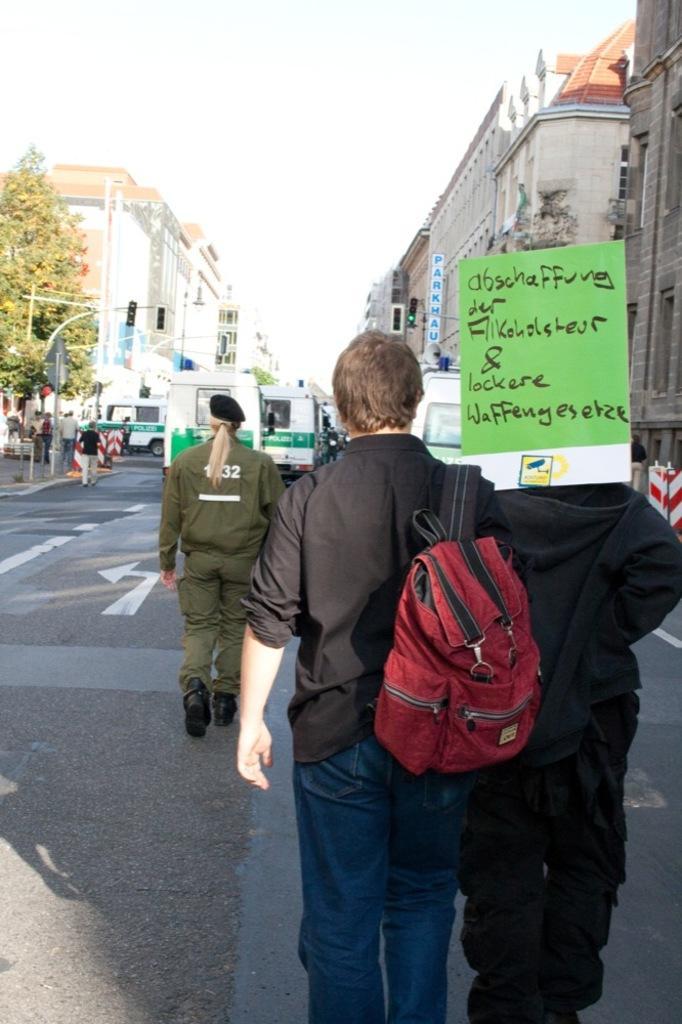Please provide a concise description of this image. This picture is taken on the road in which there are people walking on the road. In front of them there are two ambulance which are going on the road and there is also buildings and trees in front people who are walking. 